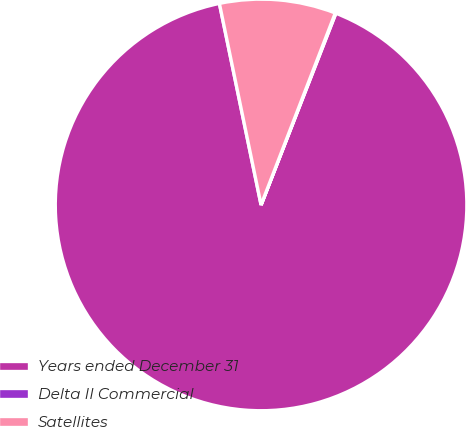<chart> <loc_0><loc_0><loc_500><loc_500><pie_chart><fcel>Years ended December 31<fcel>Delta II Commercial<fcel>Satellites<nl><fcel>90.83%<fcel>0.05%<fcel>9.12%<nl></chart> 